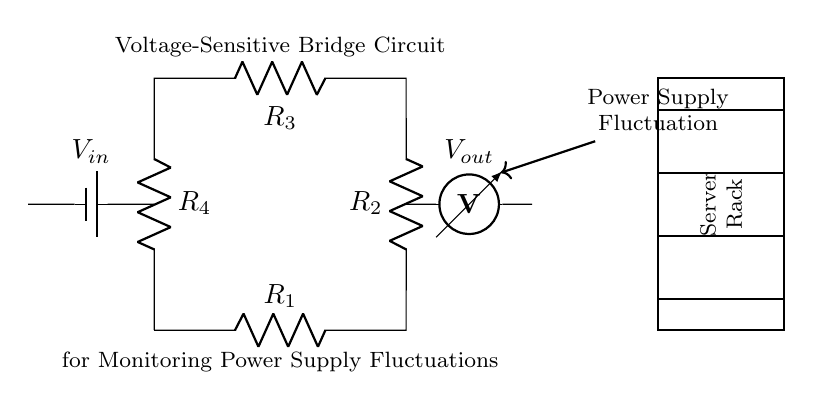What is the type of this circuit? The circuit is a bridge circuit, which is characterized by its arrangement of resistors in a closed loop that allows for the measurement of voltage differences.
Answer: Bridge circuit How many resistors are present in the circuit? The diagram shows four resistors labeled R1, R2, R3, and R4, which are part of the voltage-sensitive bridge configuration.
Answer: Four What does Vout represent? Vout is the output voltage measured across the resistors, indicative of the voltage drop or fluctuations in the circuit, particularly in response to power supply changes.
Answer: Output voltage What is indicated by the arrow leading to the server rack? The arrow indicates the direction of the power supply fluctuation, suggesting that the fluctuation information is being sent to the server rack for monitoring.
Answer: Power supply fluctuation Which component supplies voltage to the circuit? The voltage source is represented as V_in, which is the input voltage that energizes the circuit and allows current to flow through the resistors.
Answer: Battery What is the main purpose of this bridge circuit? The primary function of this circuit is to monitor power supply fluctuations in server racks, ensuring stable voltage levels for optimal performance.
Answer: Monitoring power supply fluctuations What would happen if one resistor in the bridge fails? If one resistor fails, it could disrupt the balance of the bridge circuit, leading to incorrect voltage readings at Vout and unreliable monitoring of power supply conditions.
Answer: Disrupt measurement 